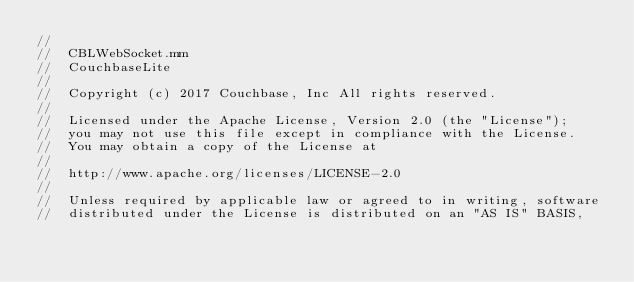<code> <loc_0><loc_0><loc_500><loc_500><_ObjectiveC_>//
//  CBLWebSocket.mm
//  CouchbaseLite
//
//  Copyright (c) 2017 Couchbase, Inc All rights reserved.
//
//  Licensed under the Apache License, Version 2.0 (the "License");
//  you may not use this file except in compliance with the License.
//  You may obtain a copy of the License at
//
//  http://www.apache.org/licenses/LICENSE-2.0
//
//  Unless required by applicable law or agreed to in writing, software
//  distributed under the License is distributed on an "AS IS" BASIS,</code> 